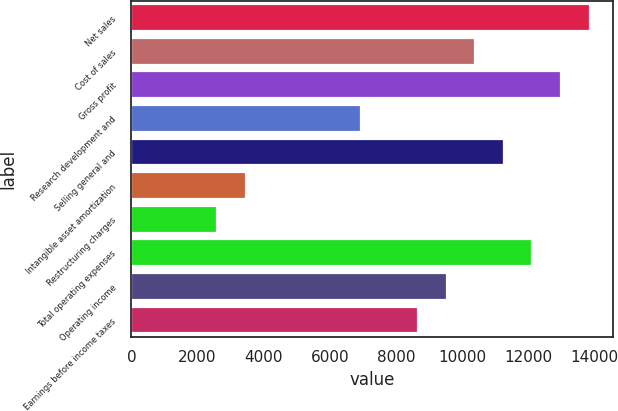Convert chart to OTSL. <chart><loc_0><loc_0><loc_500><loc_500><bar_chart><fcel>Net sales<fcel>Cost of sales<fcel>Gross profit<fcel>Research development and<fcel>Selling general and<fcel>Intangible asset amortization<fcel>Restructuring charges<fcel>Total operating expenses<fcel>Operating income<fcel>Earnings before income taxes<nl><fcel>13849.8<fcel>10387.9<fcel>12984.3<fcel>6926.08<fcel>11253.4<fcel>3464.24<fcel>2598.78<fcel>12118.8<fcel>9522.46<fcel>8657<nl></chart> 